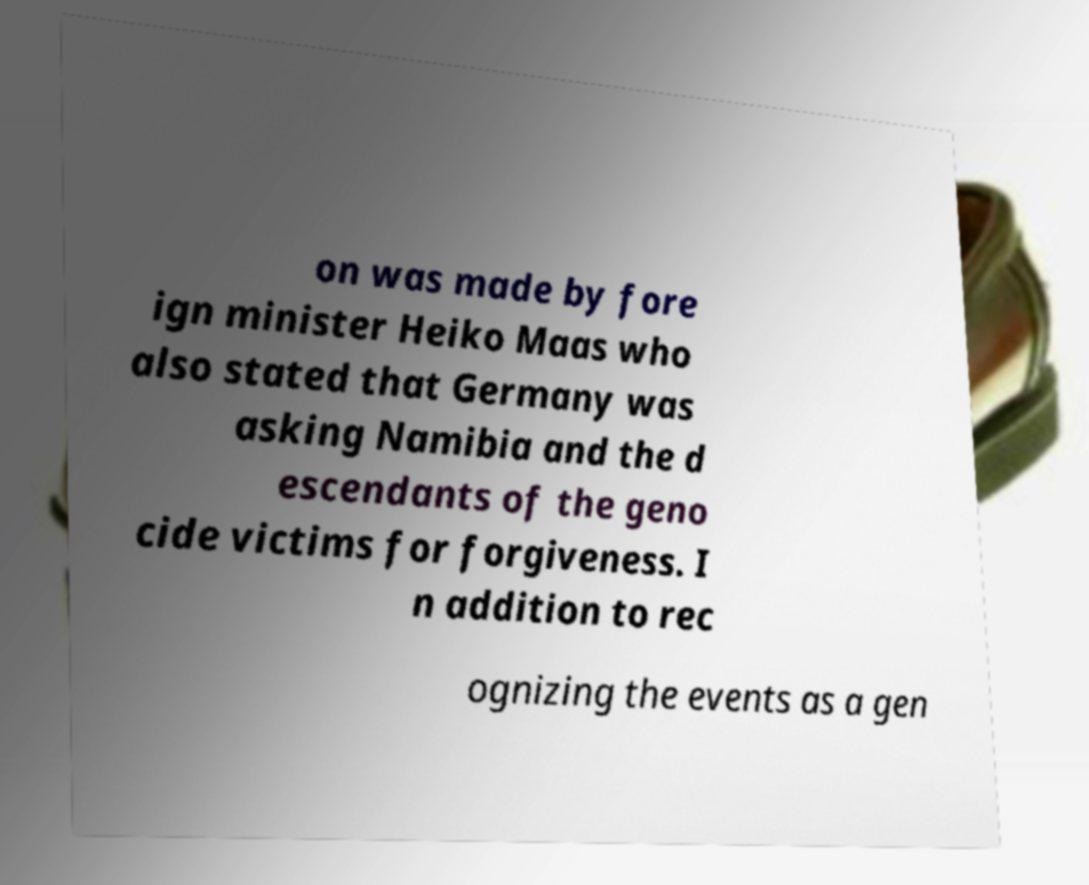Could you extract and type out the text from this image? on was made by fore ign minister Heiko Maas who also stated that Germany was asking Namibia and the d escendants of the geno cide victims for forgiveness. I n addition to rec ognizing the events as a gen 